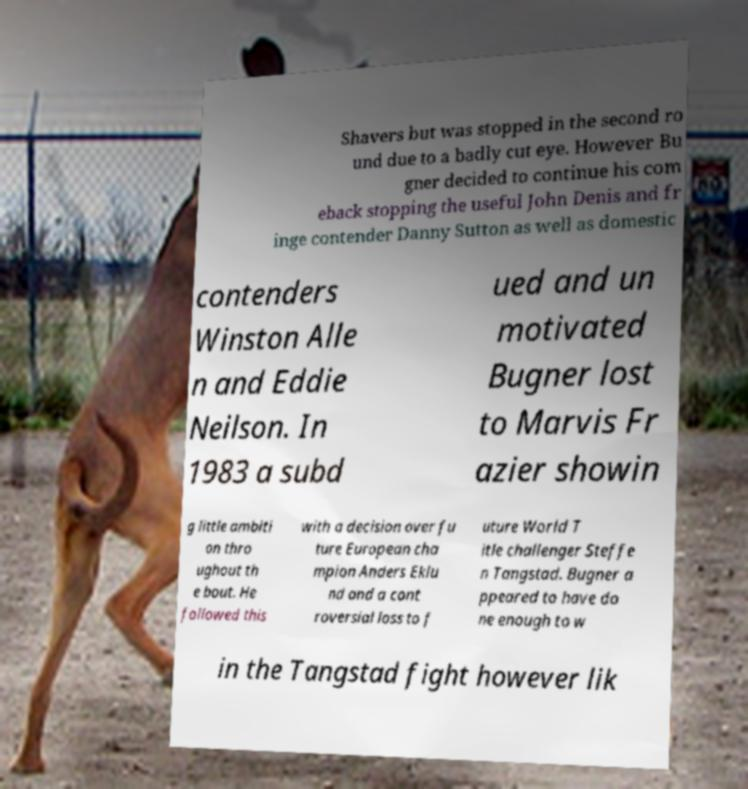Can you read and provide the text displayed in the image?This photo seems to have some interesting text. Can you extract and type it out for me? Shavers but was stopped in the second ro und due to a badly cut eye. However Bu gner decided to continue his com eback stopping the useful John Denis and fr inge contender Danny Sutton as well as domestic contenders Winston Alle n and Eddie Neilson. In 1983 a subd ued and un motivated Bugner lost to Marvis Fr azier showin g little ambiti on thro ughout th e bout. He followed this with a decision over fu ture European cha mpion Anders Eklu nd and a cont roversial loss to f uture World T itle challenger Steffe n Tangstad. Bugner a ppeared to have do ne enough to w in the Tangstad fight however lik 